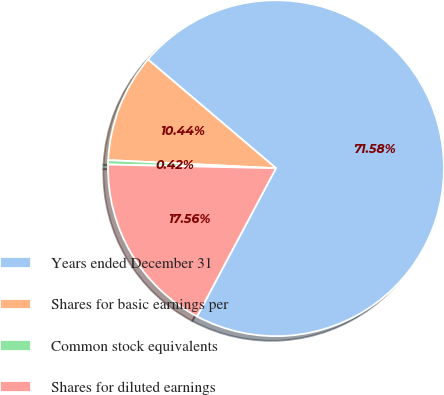Convert chart. <chart><loc_0><loc_0><loc_500><loc_500><pie_chart><fcel>Years ended December 31<fcel>Shares for basic earnings per<fcel>Common stock equivalents<fcel>Shares for diluted earnings<nl><fcel>71.59%<fcel>10.44%<fcel>0.42%<fcel>17.56%<nl></chart> 